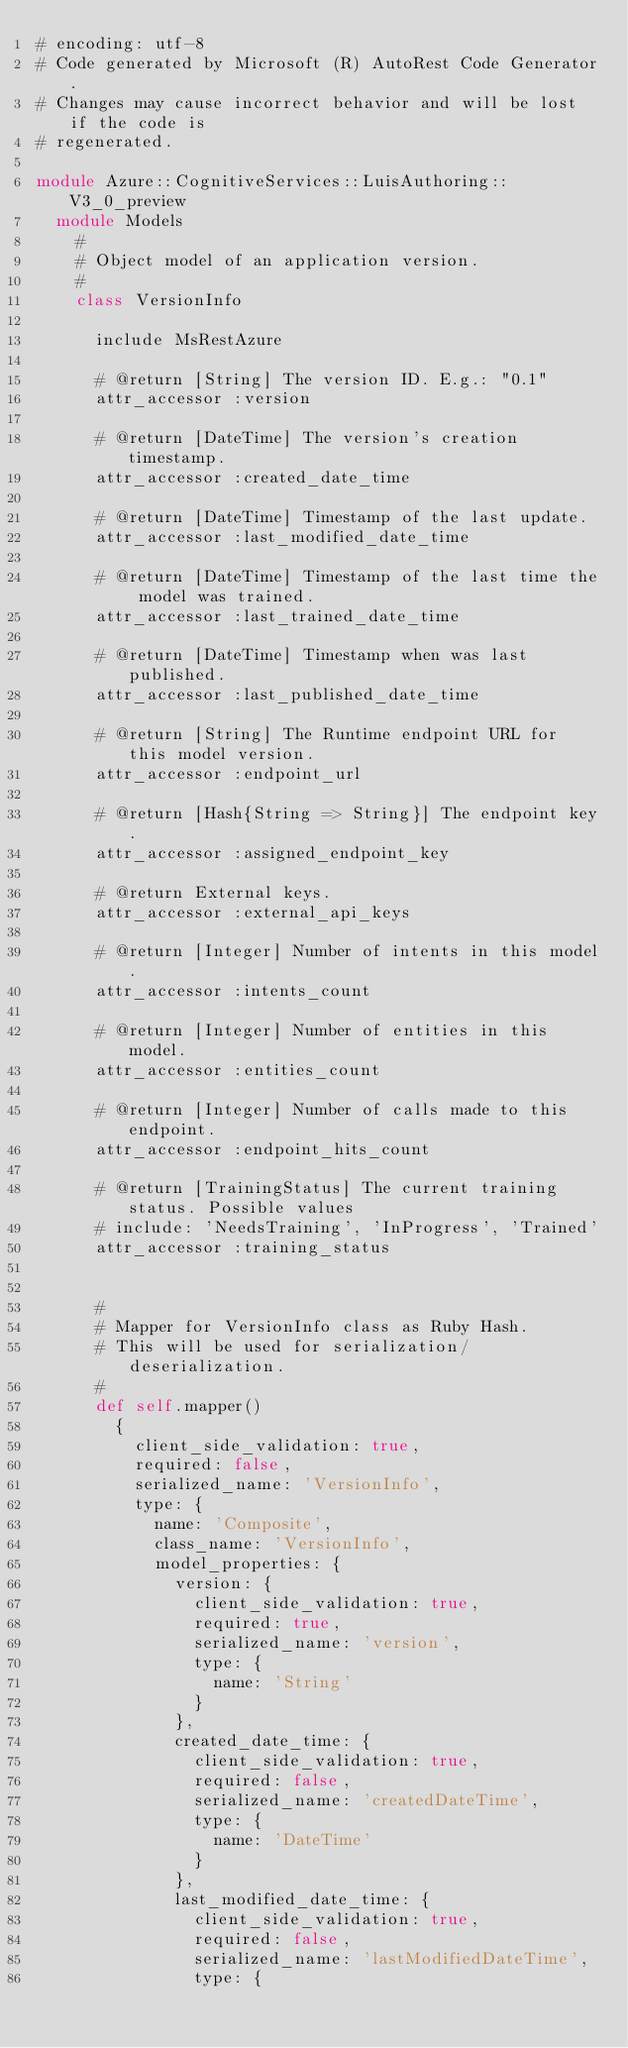Convert code to text. <code><loc_0><loc_0><loc_500><loc_500><_Ruby_># encoding: utf-8
# Code generated by Microsoft (R) AutoRest Code Generator.
# Changes may cause incorrect behavior and will be lost if the code is
# regenerated.

module Azure::CognitiveServices::LuisAuthoring::V3_0_preview
  module Models
    #
    # Object model of an application version.
    #
    class VersionInfo

      include MsRestAzure

      # @return [String] The version ID. E.g.: "0.1"
      attr_accessor :version

      # @return [DateTime] The version's creation timestamp.
      attr_accessor :created_date_time

      # @return [DateTime] Timestamp of the last update.
      attr_accessor :last_modified_date_time

      # @return [DateTime] Timestamp of the last time the model was trained.
      attr_accessor :last_trained_date_time

      # @return [DateTime] Timestamp when was last published.
      attr_accessor :last_published_date_time

      # @return [String] The Runtime endpoint URL for this model version.
      attr_accessor :endpoint_url

      # @return [Hash{String => String}] The endpoint key.
      attr_accessor :assigned_endpoint_key

      # @return External keys.
      attr_accessor :external_api_keys

      # @return [Integer] Number of intents in this model.
      attr_accessor :intents_count

      # @return [Integer] Number of entities in this model.
      attr_accessor :entities_count

      # @return [Integer] Number of calls made to this endpoint.
      attr_accessor :endpoint_hits_count

      # @return [TrainingStatus] The current training status. Possible values
      # include: 'NeedsTraining', 'InProgress', 'Trained'
      attr_accessor :training_status


      #
      # Mapper for VersionInfo class as Ruby Hash.
      # This will be used for serialization/deserialization.
      #
      def self.mapper()
        {
          client_side_validation: true,
          required: false,
          serialized_name: 'VersionInfo',
          type: {
            name: 'Composite',
            class_name: 'VersionInfo',
            model_properties: {
              version: {
                client_side_validation: true,
                required: true,
                serialized_name: 'version',
                type: {
                  name: 'String'
                }
              },
              created_date_time: {
                client_side_validation: true,
                required: false,
                serialized_name: 'createdDateTime',
                type: {
                  name: 'DateTime'
                }
              },
              last_modified_date_time: {
                client_side_validation: true,
                required: false,
                serialized_name: 'lastModifiedDateTime',
                type: {</code> 